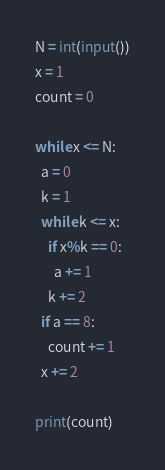<code> <loc_0><loc_0><loc_500><loc_500><_Python_>N = int(input())
x = 1
count = 0

while x <= N:
  a = 0
  k = 1
  while k <= x:
    if x%k == 0:
      a += 1
    k += 2
  if a == 8:
    count += 1
  x += 2

print(count)</code> 